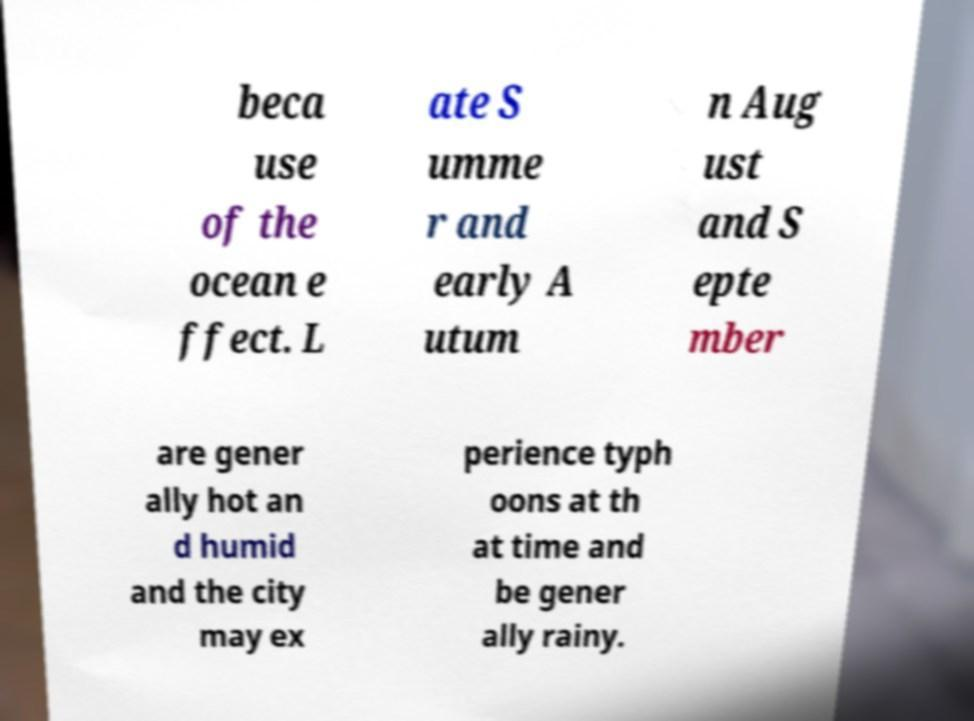There's text embedded in this image that I need extracted. Can you transcribe it verbatim? beca use of the ocean e ffect. L ate S umme r and early A utum n Aug ust and S epte mber are gener ally hot an d humid and the city may ex perience typh oons at th at time and be gener ally rainy. 